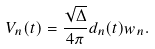Convert formula to latex. <formula><loc_0><loc_0><loc_500><loc_500>V _ { n } ( t ) = \frac { \sqrt { \Delta } } { 4 \pi } d _ { n } ( t ) w _ { n } .</formula> 